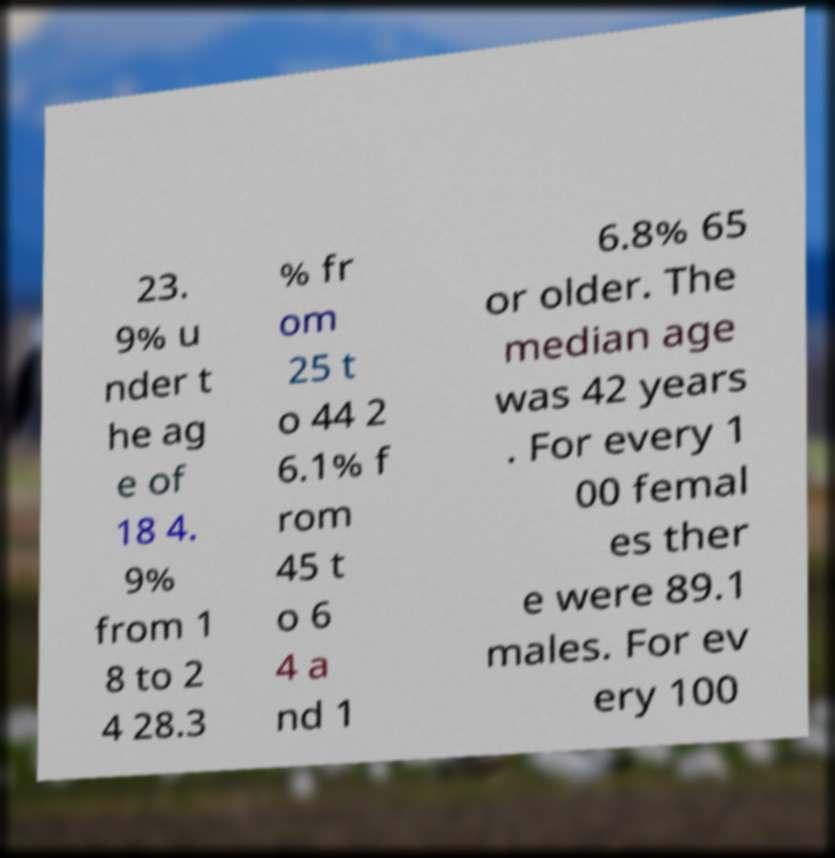Could you assist in decoding the text presented in this image and type it out clearly? 23. 9% u nder t he ag e of 18 4. 9% from 1 8 to 2 4 28.3 % fr om 25 t o 44 2 6.1% f rom 45 t o 6 4 a nd 1 6.8% 65 or older. The median age was 42 years . For every 1 00 femal es ther e were 89.1 males. For ev ery 100 